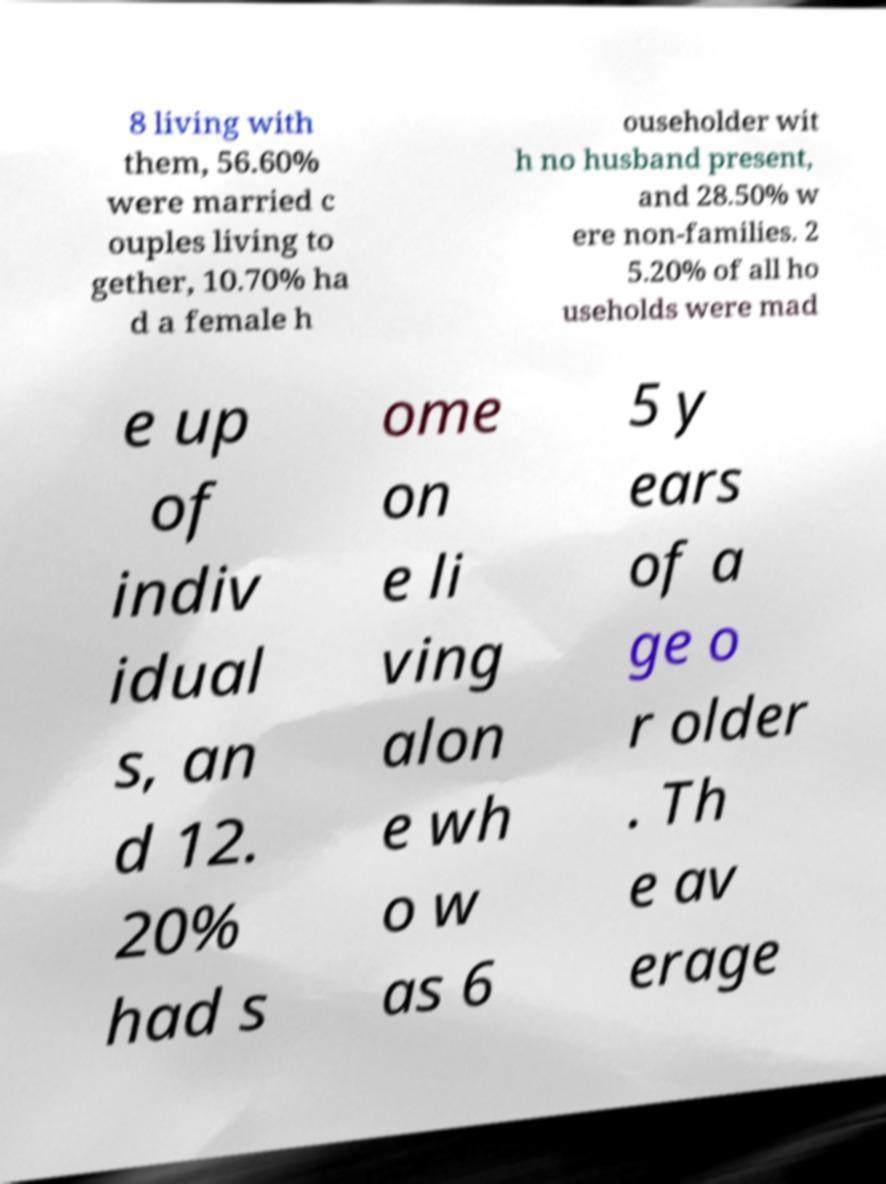For documentation purposes, I need the text within this image transcribed. Could you provide that? 8 living with them, 56.60% were married c ouples living to gether, 10.70% ha d a female h ouseholder wit h no husband present, and 28.50% w ere non-families. 2 5.20% of all ho useholds were mad e up of indiv idual s, an d 12. 20% had s ome on e li ving alon e wh o w as 6 5 y ears of a ge o r older . Th e av erage 